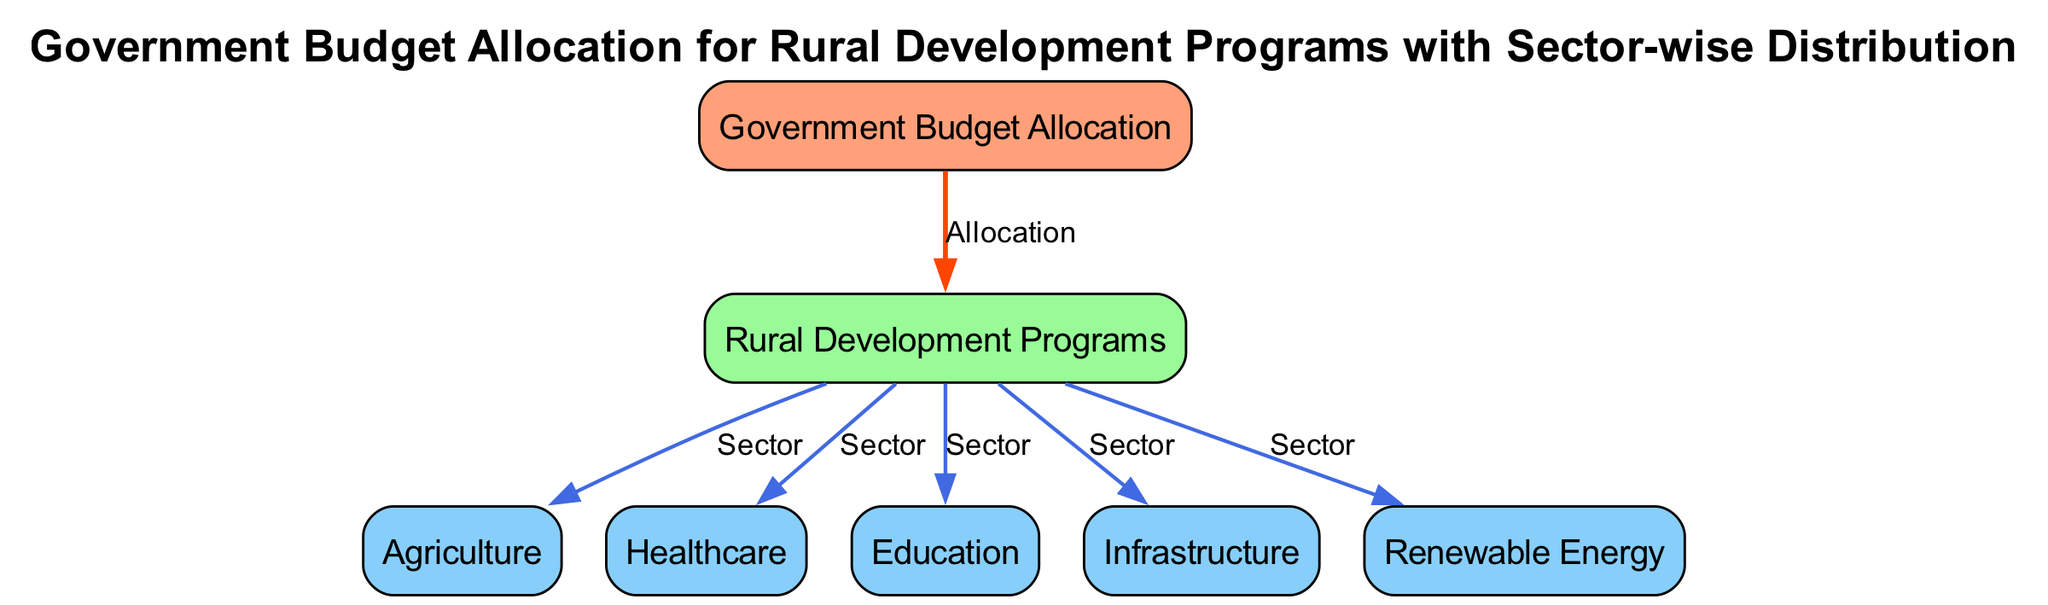What is the main focus of the diagram? The diagram is structured around the concept of "Government Budget Allocation," which serves as the main node. This can be identified by looking at the node labeled "Government Budget Allocation," which is the central theme from which all other elements are derived.
Answer: Government Budget Allocation How many sectors are included under Rural Development Programs? The diagram displays a total of five sectors that fall under "Rural Development Programs." By counting the sector nodes connected to the "Rural Development Programs" node, we find agriculture, healthcare, education, infrastructure, and renewable energy.
Answer: 5 Which sector is directly connected to the rural development category? The diagram shows that all sector nodes (agriculture, healthcare, education, infrastructure, and renewable energy) are directly connected to the "Rural Development Programs" node. Therefore, any of these sectors can be considered directly connected to rural development.
Answer: Agriculture, Healthcare, Education, Infrastructure, Renewable Energy What type of relationship connects the budget allocation and rural development programs? The relationship between the "Government Budget Allocation" node and the "Rural Development Programs" node is labeled as "Allocation." This indicates that the budget allocation is directed toward rural development initiatives.
Answer: Allocation Which sector is likely to receive funding for environmental initiatives? The "Renewable Energy" sector is most likely to receive funding for environmental initiatives, as it is specifically labeled as being focused on renewable energy solutions. This sector stands out in relation to sustainability and environmental concerns.
Answer: Renewable Energy What color represents the sector nodes in the diagram? The sector nodes, which include agriculture, healthcare, education, infrastructure, and renewable energy, are represented in light blue (or #87CEFA) as indicated by the color coding in the diagram specification.
Answer: Light Blue Which node represents the category encompassing various sectors? The node labeled "Rural Development Programs" functions as the category under which the various sectors are grouped. It connects to multiple sectors, providing a central categorization of resources allocated to rural development.
Answer: Rural Development Programs How many edges connect the sectors to the rural development programs? There are five edges connecting the sectors to the "Rural Development Programs" node, as each sector (agriculture, healthcare, education, infrastructure, and renewable energy) has its own connecting edge labeled "Sector."
Answer: 5 What does the label on the edge between the government budget allocation and rural development represent? The edge labeled as "Allocation" indicates the flow of budget resources from the government to the category of rural development programs, highlighting the connection and purpose of funding distributions.
Answer: Allocation 